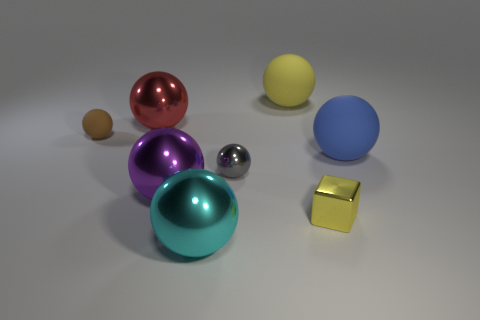Subtract all small balls. How many balls are left? 5 Subtract 2 balls. How many balls are left? 5 Subtract all purple balls. How many balls are left? 6 Add 1 red objects. How many objects exist? 9 Subtract all gray spheres. Subtract all cyan cylinders. How many spheres are left? 6 Subtract all cubes. How many objects are left? 7 Subtract all small red matte cylinders. Subtract all large matte things. How many objects are left? 6 Add 3 small gray metallic spheres. How many small gray metallic spheres are left? 4 Add 5 small brown metallic cylinders. How many small brown metallic cylinders exist? 5 Subtract 0 gray blocks. How many objects are left? 8 